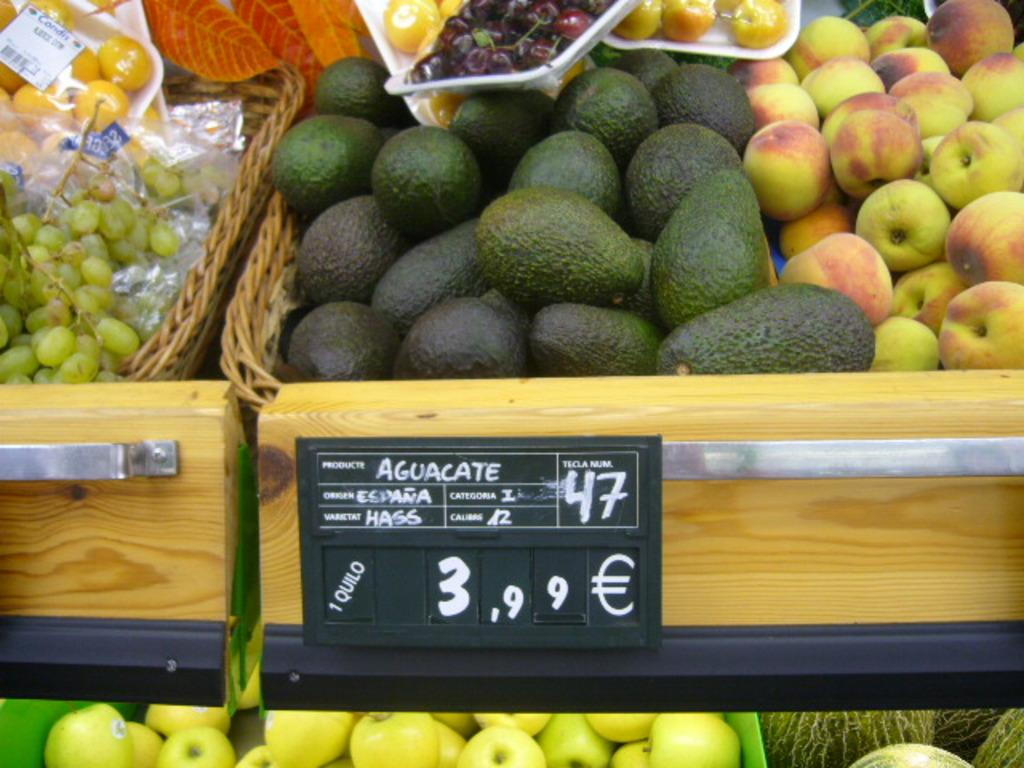What type of fruits can be seen in the image? There are apples, avocados, grapes, and other fruits in the image. How are the fruits arranged or displayed in the image? The fruits are in baskets in the image. What else can be seen in the image besides the fruits? There is a board in the image. Are there any pets involved in a fight in the image? There are no pets or fights present in the image. 